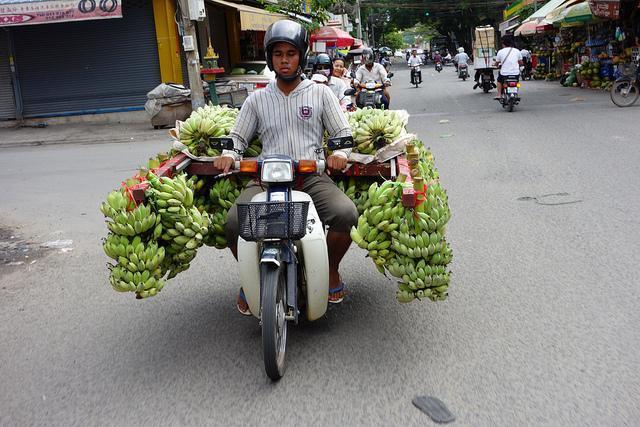How many bananas are there?
Give a very brief answer. 3. How many chairs with cushions are there?
Give a very brief answer. 0. 